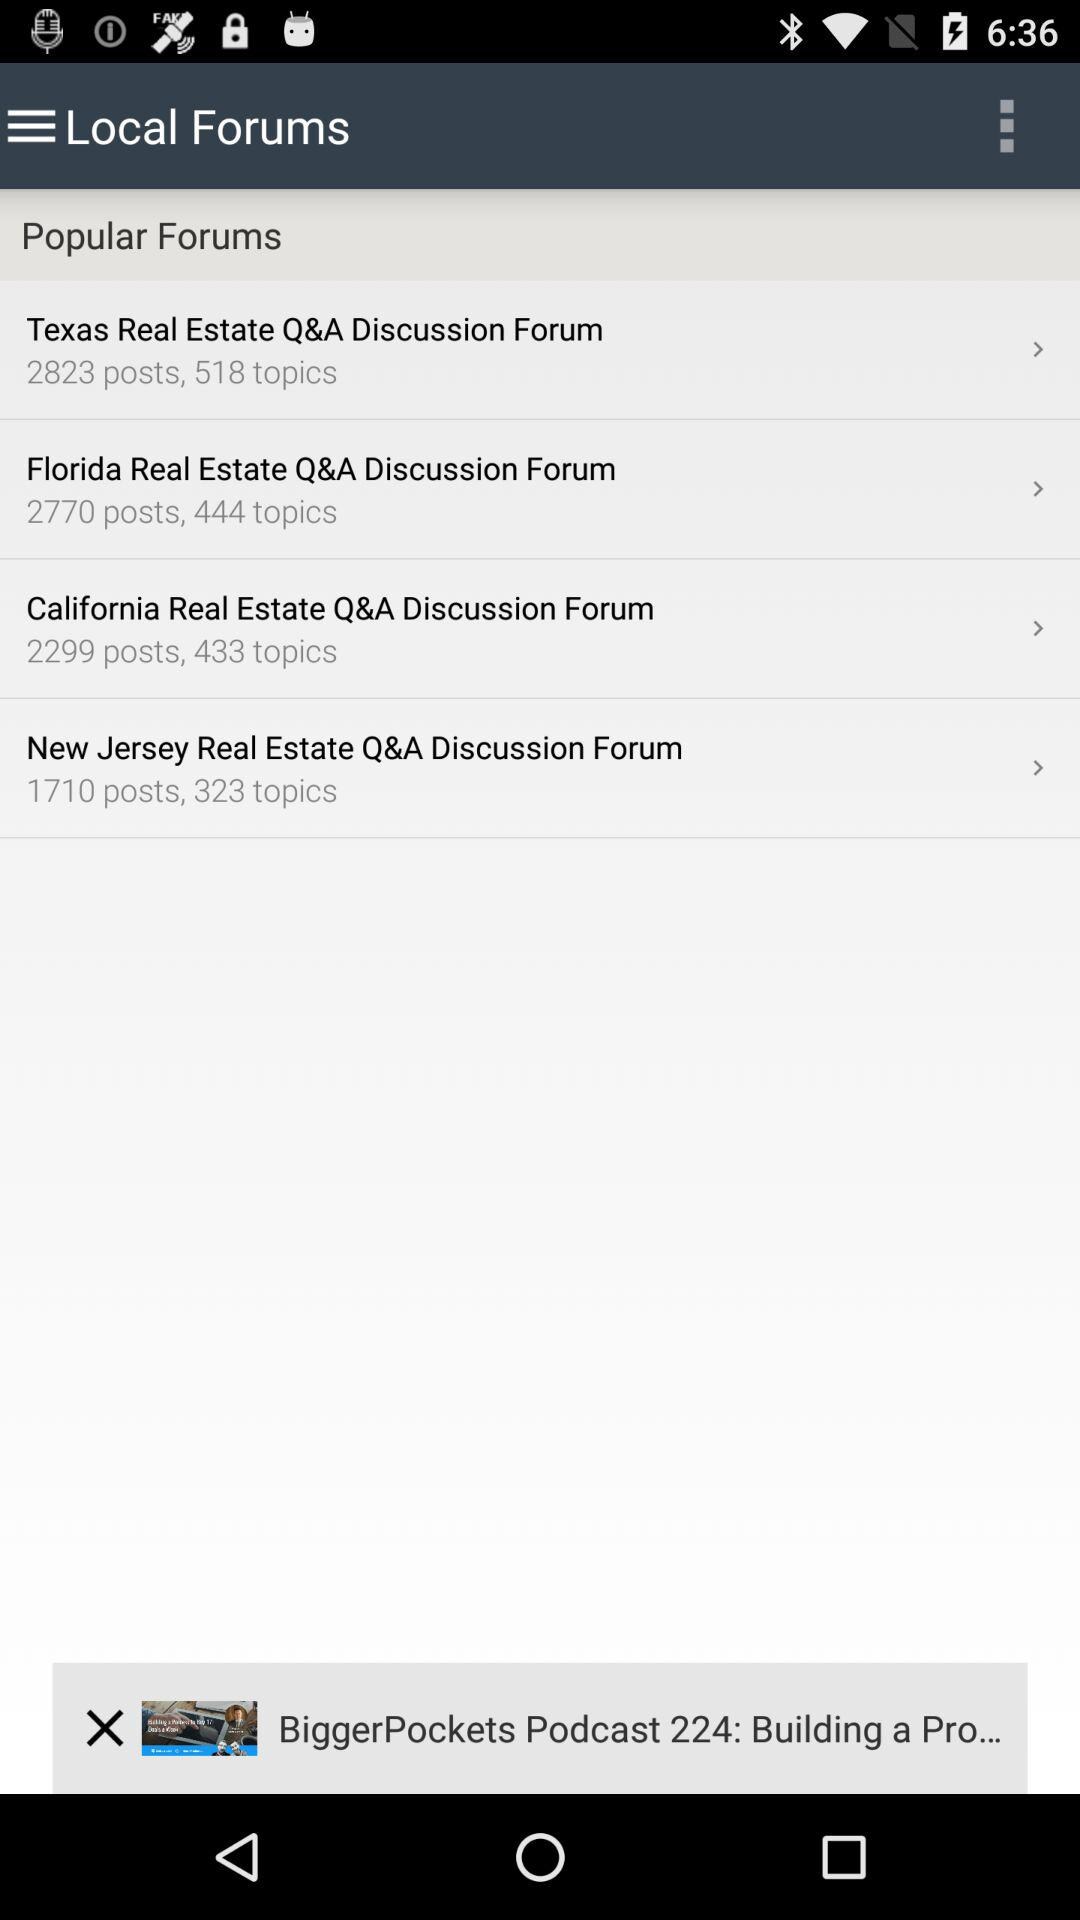How many more topics are in the California Real Estate Q&A Discussion Forum than the New Jersey Real Estate Q&A Discussion Forum?
Answer the question using a single word or phrase. 110 